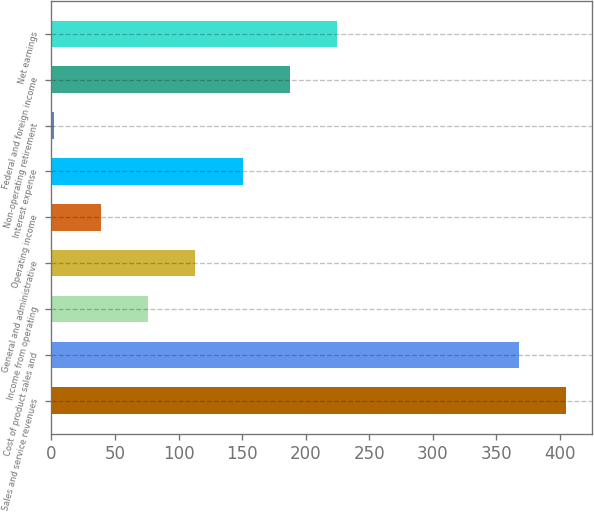Convert chart to OTSL. <chart><loc_0><loc_0><loc_500><loc_500><bar_chart><fcel>Sales and service revenues<fcel>Cost of product sales and<fcel>Income from operating<fcel>General and administrative<fcel>Operating income<fcel>Interest expense<fcel>Non-operating retirement<fcel>Federal and foreign income<fcel>Net earnings<nl><fcel>405.1<fcel>368<fcel>76.2<fcel>113.3<fcel>39.1<fcel>150.4<fcel>2<fcel>187.5<fcel>224.6<nl></chart> 